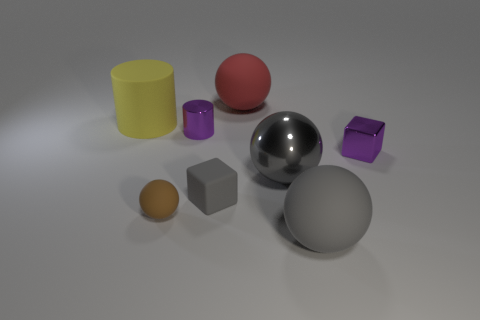Add 1 small yellow spheres. How many objects exist? 9 Subtract all blocks. How many objects are left? 6 Add 4 small purple shiny cubes. How many small purple shiny cubes are left? 5 Add 6 gray blocks. How many gray blocks exist? 7 Subtract 0 red cubes. How many objects are left? 8 Subtract all cyan things. Subtract all tiny rubber things. How many objects are left? 6 